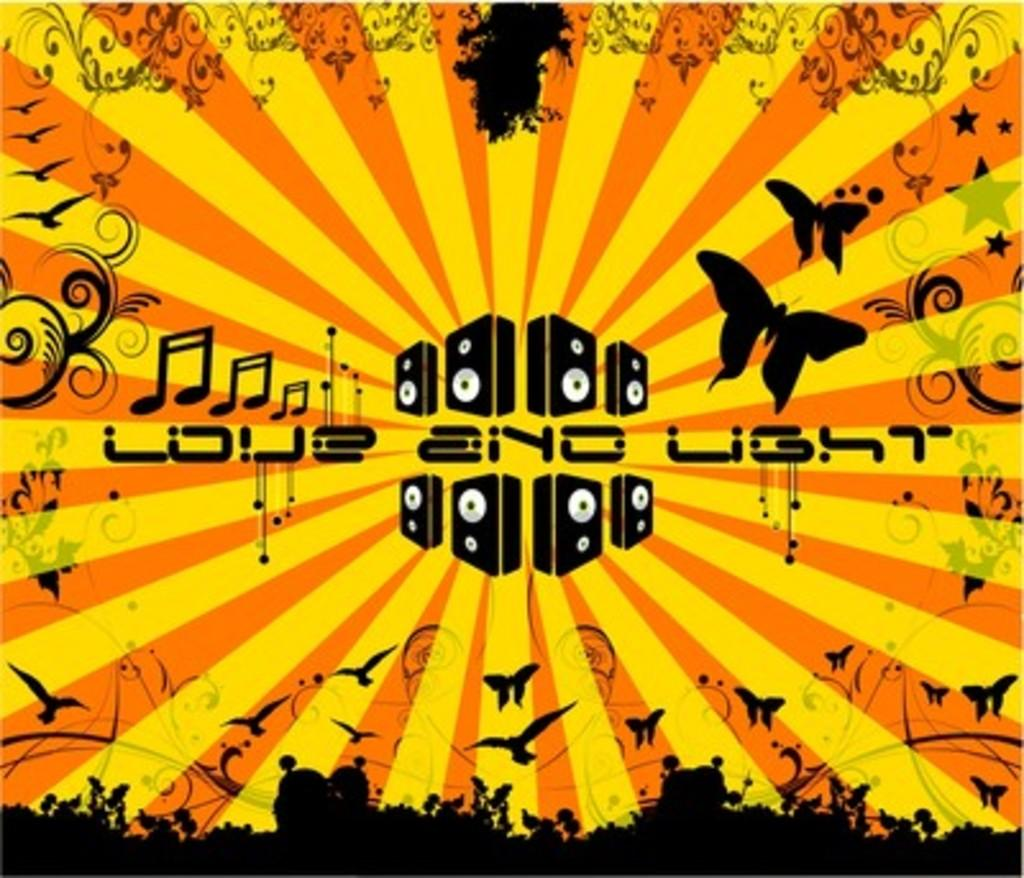<image>
Relay a brief, clear account of the picture shown. Love and light with a yellow and orange background with butterflies. 